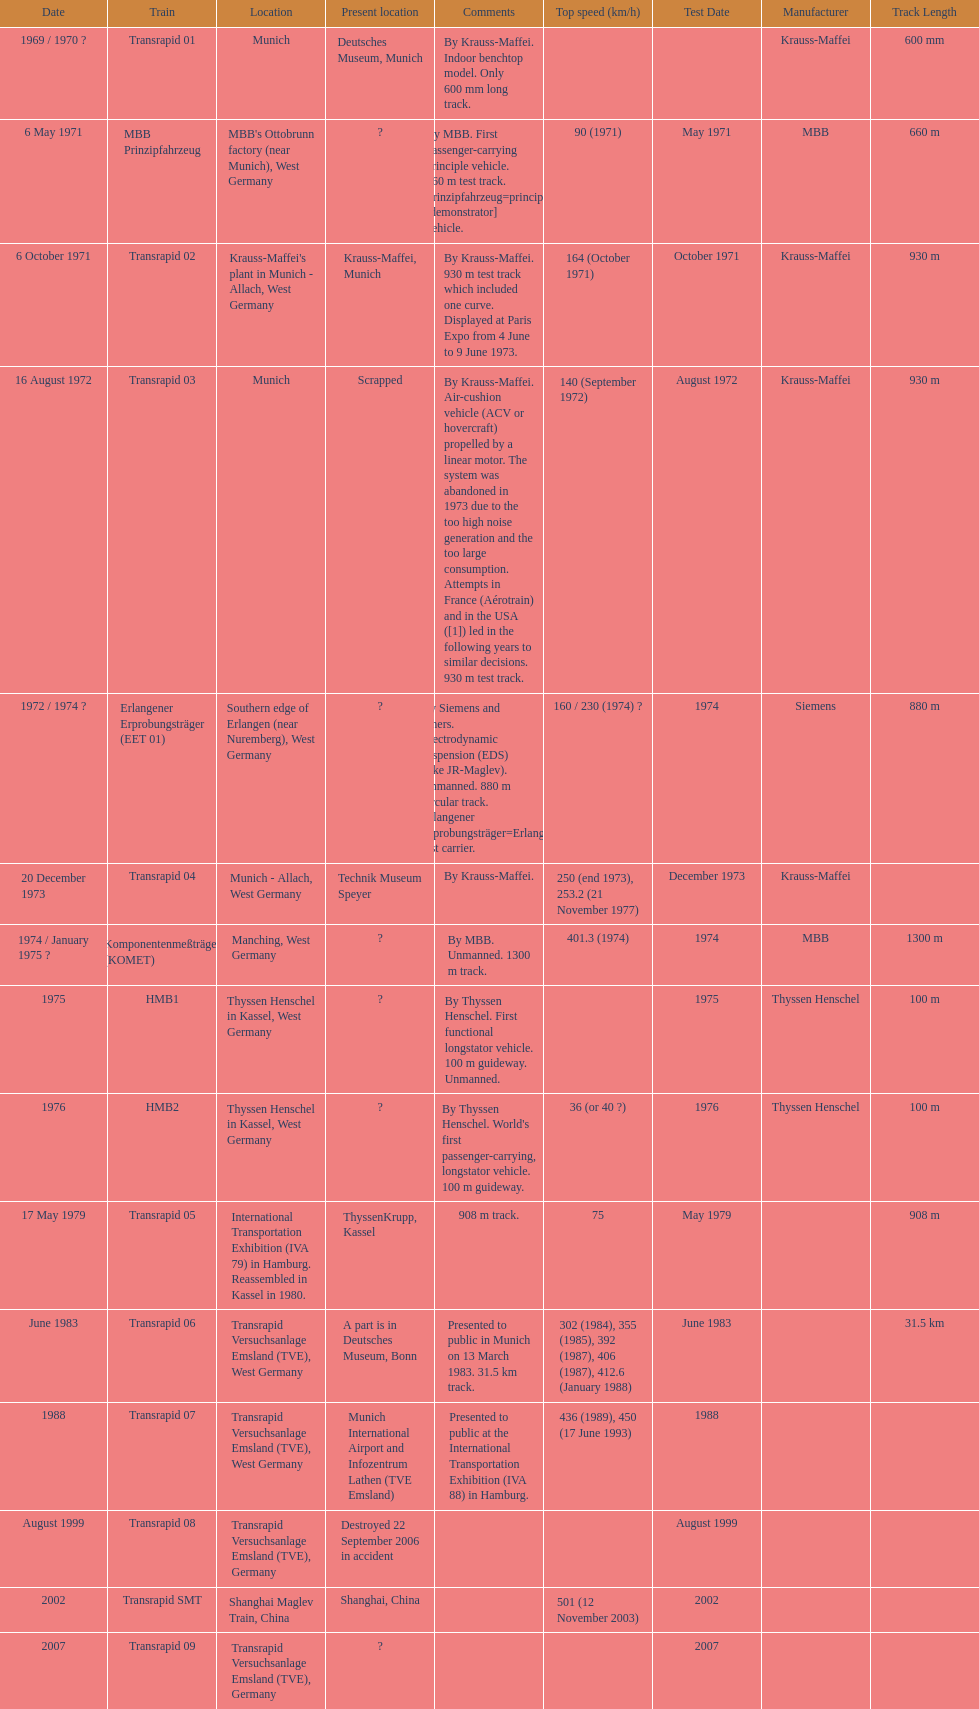Tell me the number of versions that are scrapped. 1. 